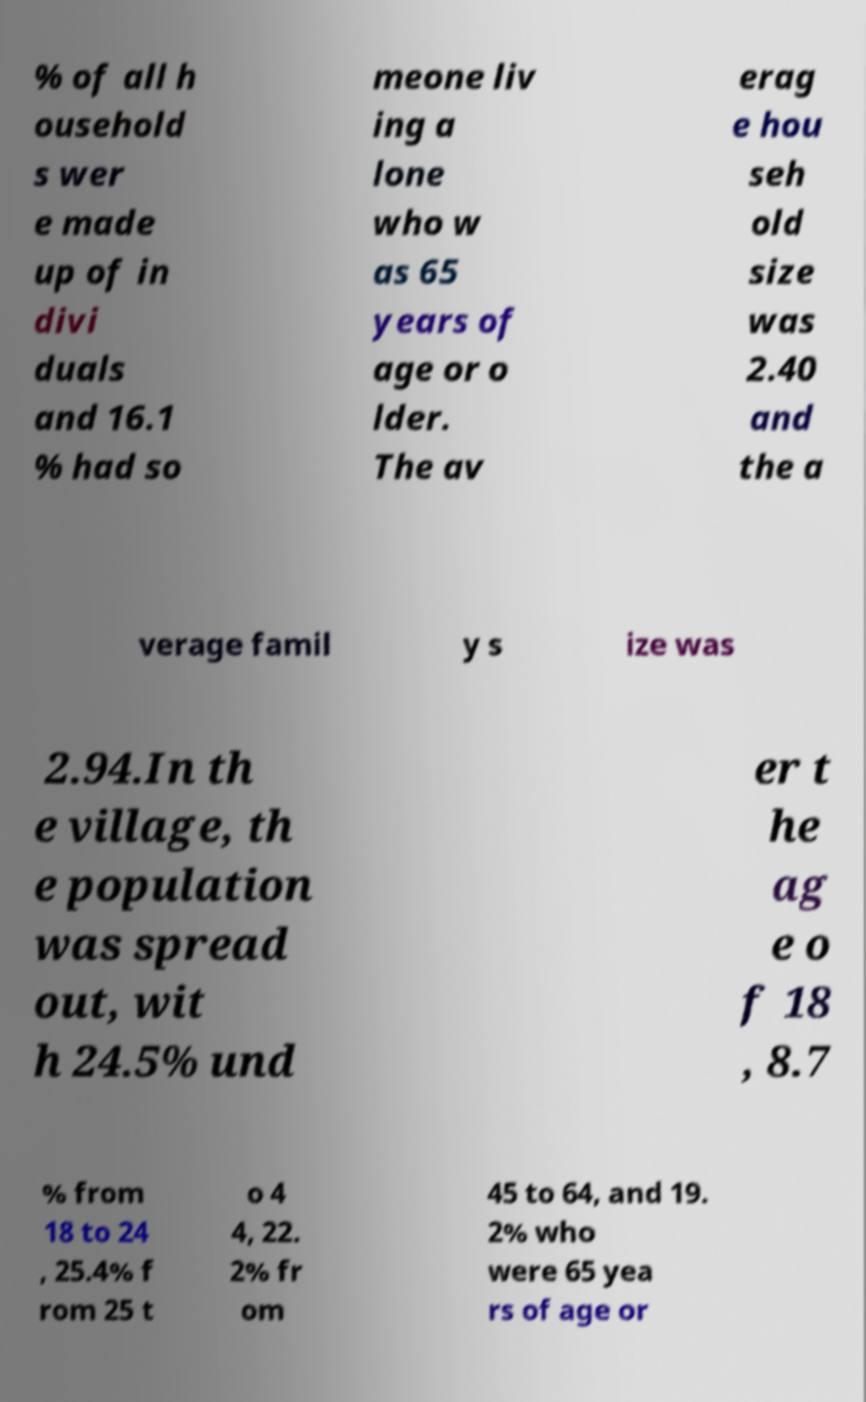What messages or text are displayed in this image? I need them in a readable, typed format. % of all h ousehold s wer e made up of in divi duals and 16.1 % had so meone liv ing a lone who w as 65 years of age or o lder. The av erag e hou seh old size was 2.40 and the a verage famil y s ize was 2.94.In th e village, th e population was spread out, wit h 24.5% und er t he ag e o f 18 , 8.7 % from 18 to 24 , 25.4% f rom 25 t o 4 4, 22. 2% fr om 45 to 64, and 19. 2% who were 65 yea rs of age or 